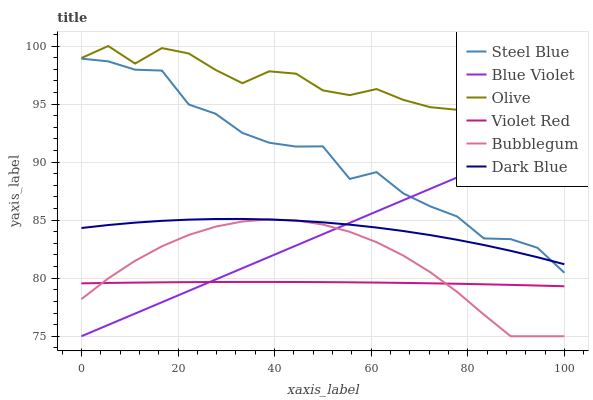Does Violet Red have the minimum area under the curve?
Answer yes or no. Yes. Does Olive have the maximum area under the curve?
Answer yes or no. Yes. Does Steel Blue have the minimum area under the curve?
Answer yes or no. No. Does Steel Blue have the maximum area under the curve?
Answer yes or no. No. Is Blue Violet the smoothest?
Answer yes or no. Yes. Is Olive the roughest?
Answer yes or no. Yes. Is Steel Blue the smoothest?
Answer yes or no. No. Is Steel Blue the roughest?
Answer yes or no. No. Does Steel Blue have the lowest value?
Answer yes or no. No. Does Steel Blue have the highest value?
Answer yes or no. No. Is Violet Red less than Dark Blue?
Answer yes or no. Yes. Is Olive greater than Steel Blue?
Answer yes or no. Yes. Does Violet Red intersect Dark Blue?
Answer yes or no. No. 